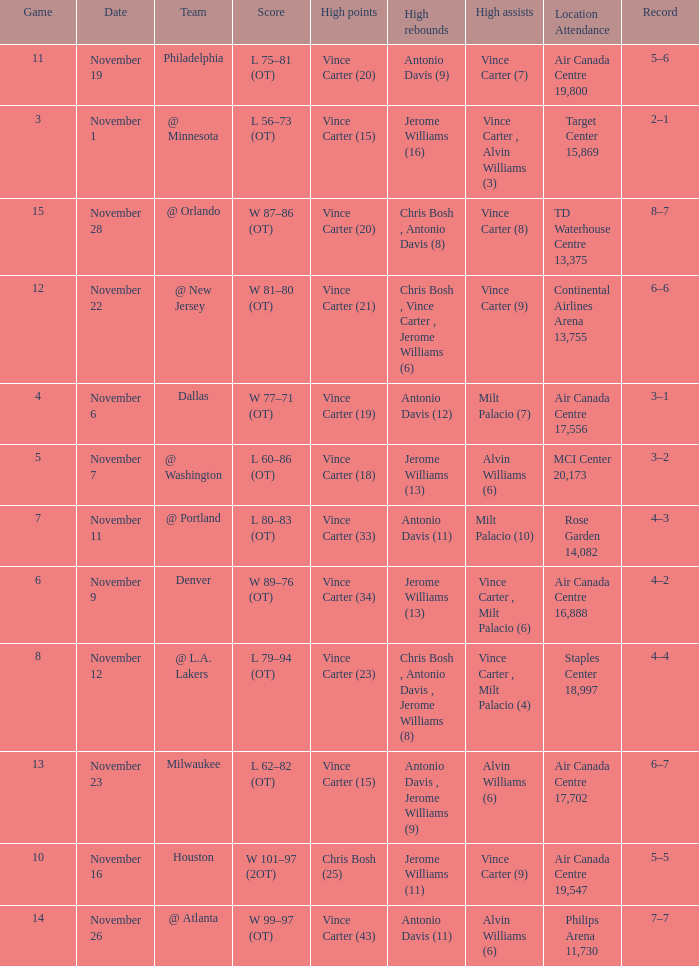On what date was the attendance at Continental Airlines Arena 13,755? November 22. 